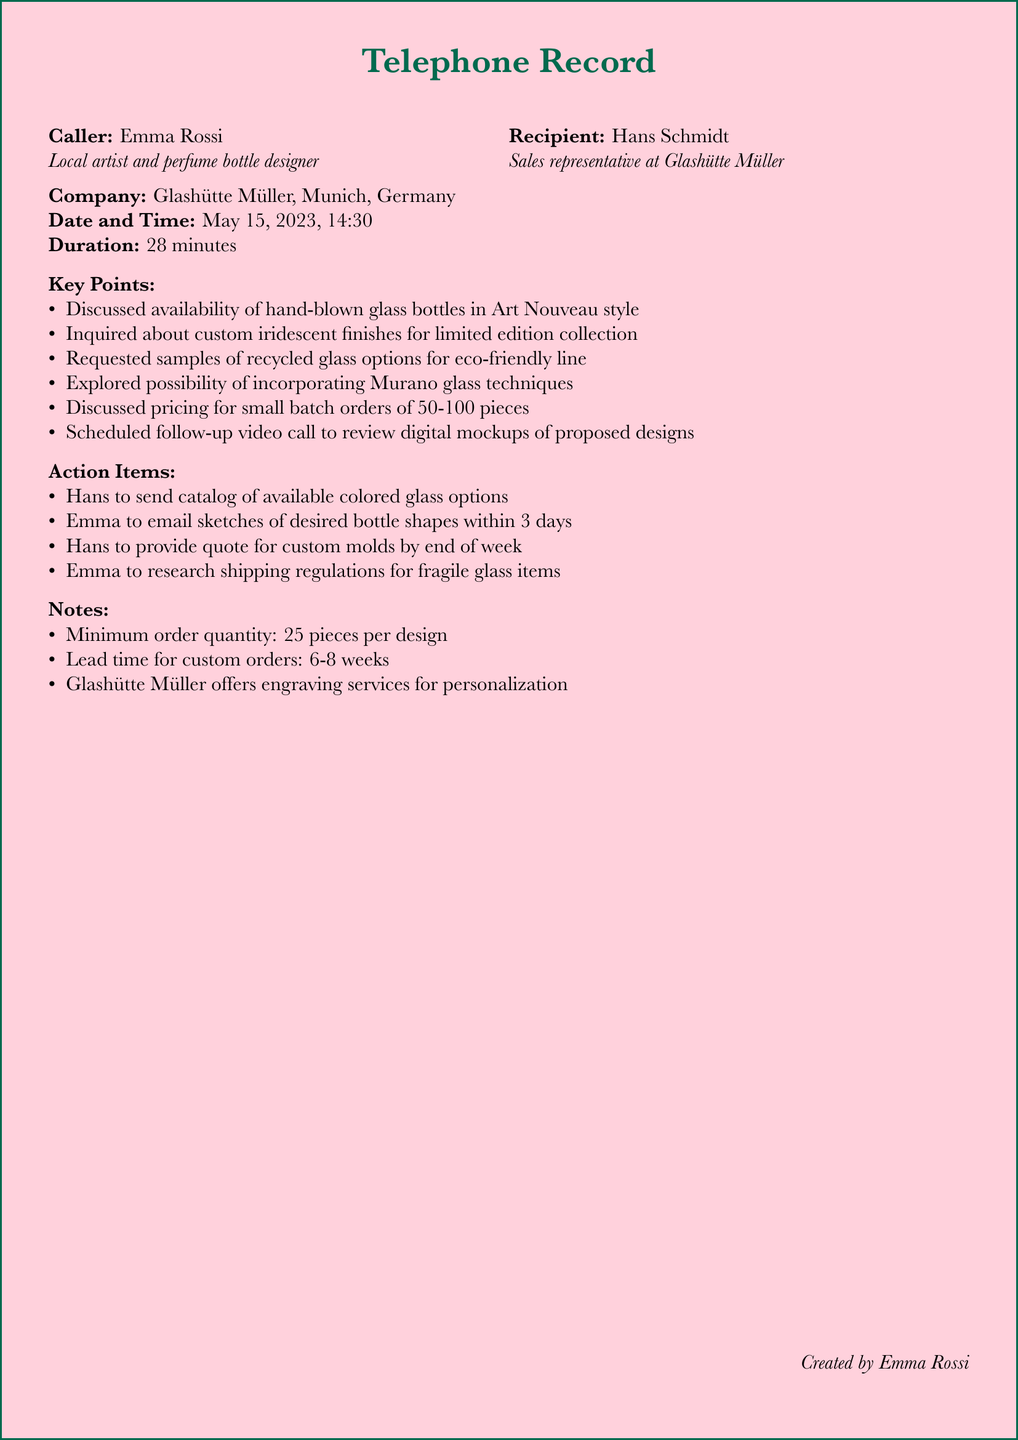What is the name of the caller? The caller's name is provided at the beginning of the document, which is Emma Rossi.
Answer: Emma Rossi Who is the recipient of the call? The recipient's name is mentioned next to the caller's name, which is Hans Schmidt.
Answer: Hans Schmidt What is the date of the call? The date and time of the call are specified in the document, which is May 15, 2023.
Answer: May 15, 2023 How long did the call last? The duration of the call is stated in the document, which is 28 minutes.
Answer: 28 minutes What style of bottles was discussed during the call? The discussed style of bottles is mentioned in the key points of the document, which is Art Nouveau style.
Answer: Art Nouveau style How many pieces are required for the minimum order? The minimum order quantity is explicitly noted in the notes section, which is 25 pieces per design.
Answer: 25 pieces What is the lead time for custom orders? The lead time for custom orders is indicated in the notes section, which is 6-8 weeks.
Answer: 6-8 weeks What action item involves sending a catalog? The action item that involves sending a catalog is related to Hans providing a catalog of available colored glass options.
Answer: Catalog of available colored glass options What did Emma agree to send within three days? The document states that Emma will email sketches of desired bottle shapes.
Answer: Sketches of desired bottle shapes 